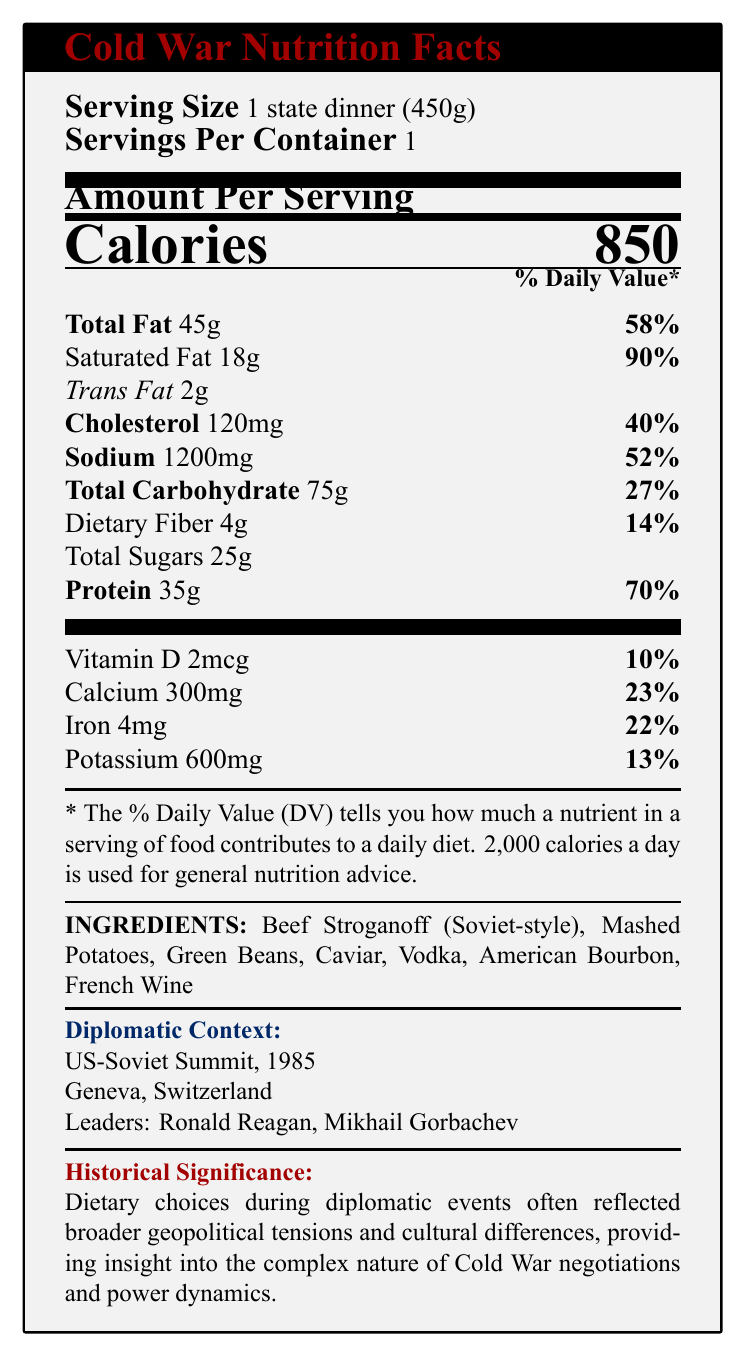what is the serving size? The document indicates that the serving size is 1 state dinner (450g) under the "Serving Size" section.
Answer: 1 state dinner (450g) how many calories are in one serving? The "Calories" section of the document states that there are 850 calories per serving.
Answer: 850 how much total fat is in one serving? Under the "Total Fat" section, the document lists 45g of total fat per serving.
Answer: 45g what percentage of the daily value for protein does one serving provide? According to the "Protein" section, one serving provides 70% of the daily value for protein.
Answer: 70% list three ingredients mentioned in the document The ingredients section lists several ingredients including Beef Stroganoff (Soviet-style), Mashed Potatoes, and Green Beans.
Answer: Beef Stroganoff (Soviet-style), Mashed Potatoes, Green Beans which leaders attended this diplomatic event? A. John F. Kennedy and Nikita Khrushchev B. Ronald Reagan and Mikhail Gorbachev C. Richard Nixon and Leonid Brezhnev The "Diplomatic Context" section mentions that the leaders were Ronald Reagan and Mikhail Gorbachev.
Answer: B how much sodium does one serving contain? The "Sodium" section notes that one serving contains 1200mg of sodium.
Answer: 1200mg what is the daily value percentage for iron in one serving? The "Iron" section indicates that one serving provides 22% of the daily value for iron.
Answer: 22% is there any information about the alcohol content in the dish? The document lists alcoholic beverages like Vodka and American Bourbon as ingredients but does not provide specific information about their alcohol content.
Answer: No which event is associated with the meal described in the document? The "Diplomatic Context" section specifies that the event is the US-Soviet Summit of 1985 held in Geneva, Switzerland.
Answer: US-Soviet Summit 1985 what is the main idea of the document? The document offers a detailed overview of the nutritional content, ingredients, and historical context of a state dinner, emphasizing how dietary choices reflect geopolitical tensions and cultural differences during the Cold War.
Answer: The document provides nutritional information for a state dinner served during the US-Soviet Summit in 1985, highlighting the ingredients, dietary trends, and historical significance of the meal. how does the document say western leaders' dietary preferences compare to soviet leaders? The "Comparative Notes" section explains that Western leaders often preferred richer, meat-heavy dishes, while Soviet leaders included more grains and vegetables, reflecting their agricultural policies.
Answer: Western leaders favored richer, meat-heavy dishes, while Soviet leaders incorporated more grains and vegetables. why did alcohol play a role in this diplomatic meal? A. To celebrate the occasion B. To facilitate informal discussions and build rapport C. For nutritional balance According to the "dietaryTrends" section, alcohol was used as a social lubricant to facilitate informal discussions and build rapport.
Answer: B how much dietary fiber is in one serving? The "Dietary Fiber" section lists 4g of dietary fiber per serving.
Answer: 4g can we determine the exact portion of Vodka or American Bourbon in the meal? The document mentions Vodka and American Bourbon as part of the ingredients but does not provide exact portions or amounts for these beverages.
Answer: Cannot be determined 